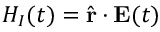<formula> <loc_0><loc_0><loc_500><loc_500>H _ { I } ( t ) = \hat { r } \cdot E ( t )</formula> 